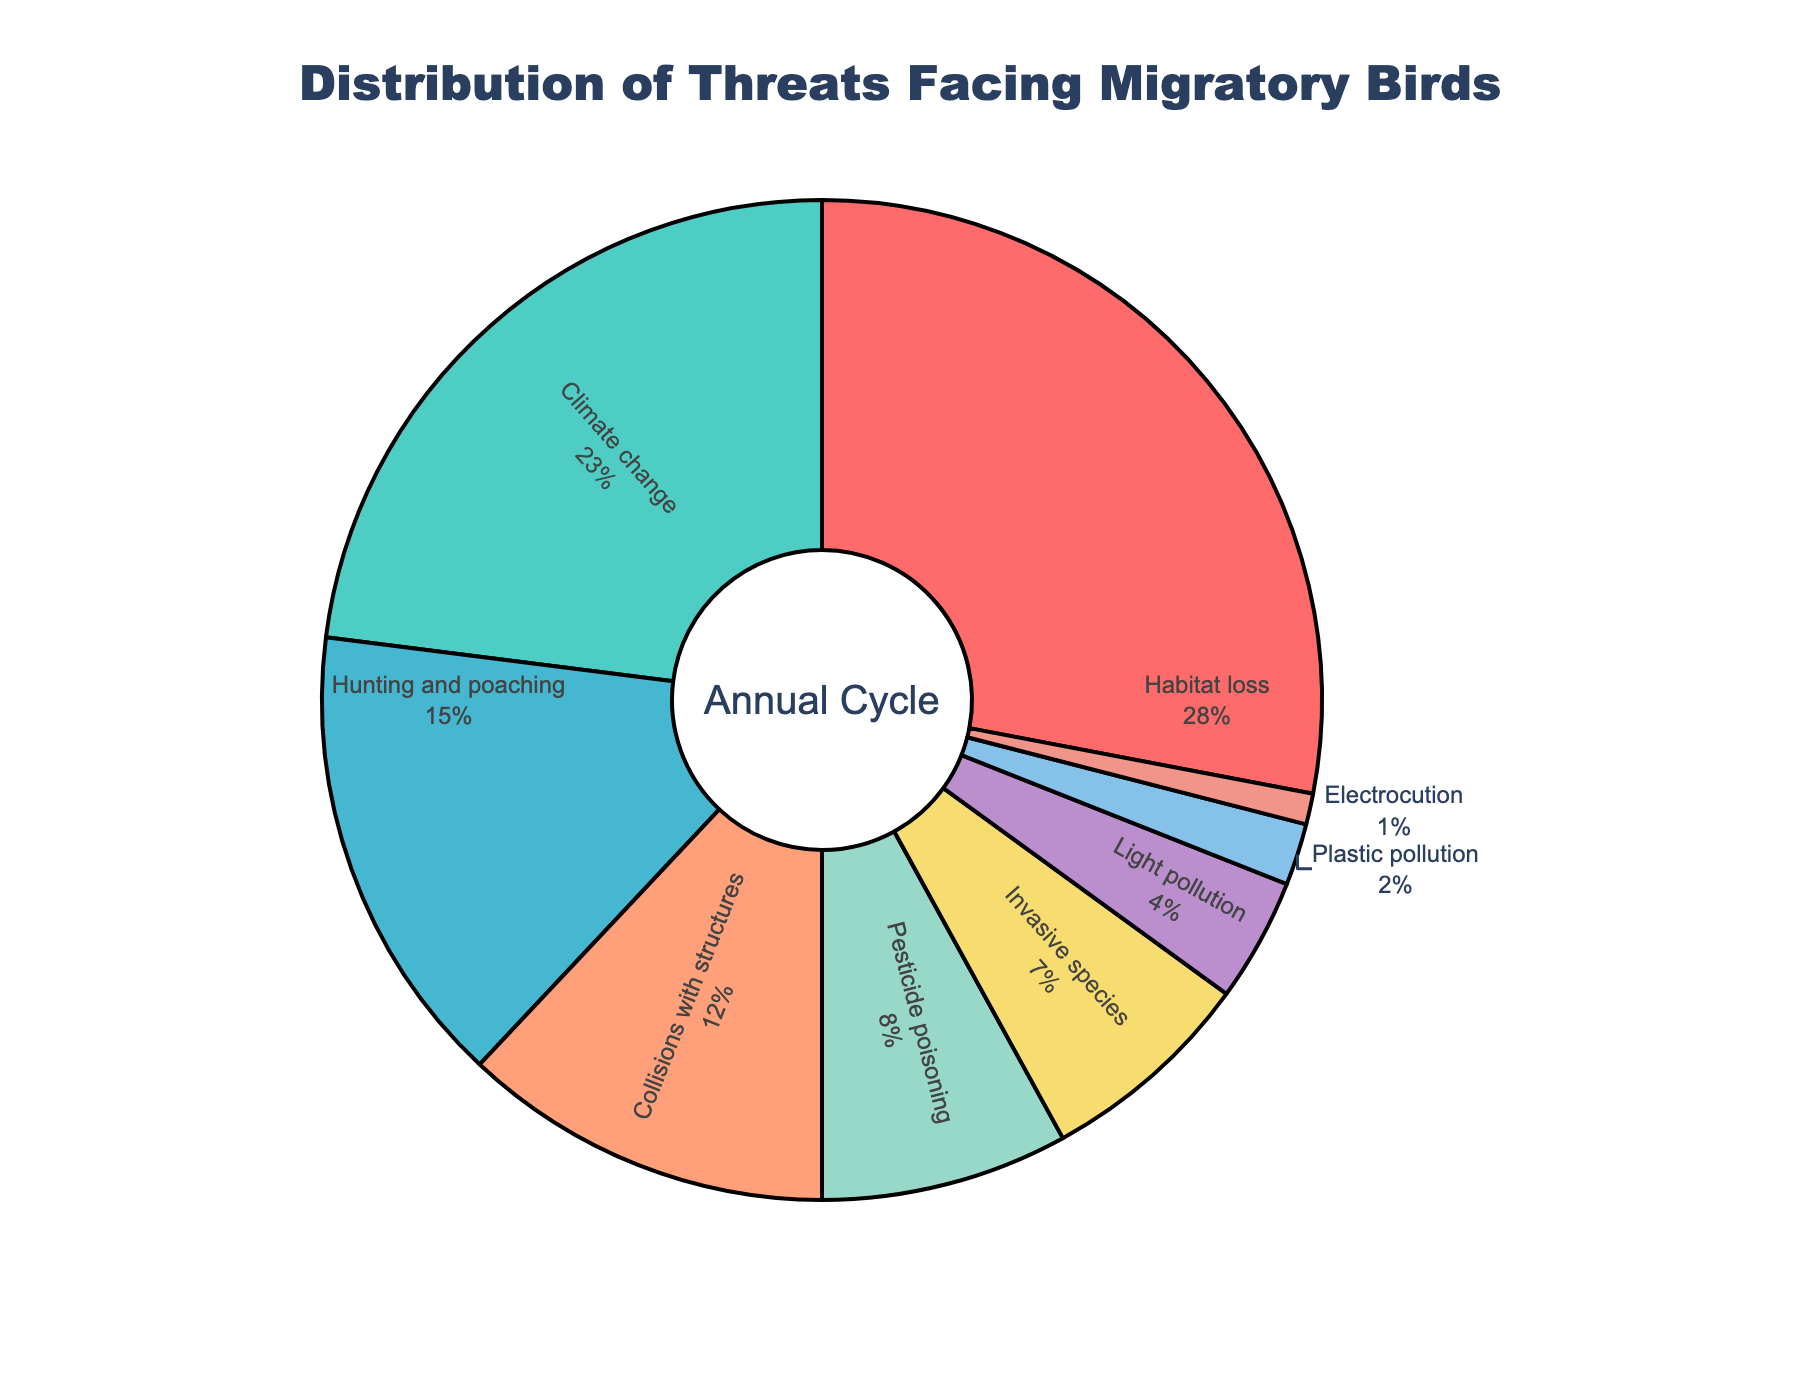What is the most significant threat facing migratory birds? According to the pie chart, the largest section represents habitat loss, which is marked with the highest percentage.
Answer: Habitat loss How much more significant is climate change compared to plastic pollution? The percentage for climate change is 23%, and for plastic pollution, it's 2%. The difference between them is 23% - 2% = 21%.
Answer: 21% Which threats together make up more than half of the total percentage? Adding the percentages of habitat loss (28%), climate change (23%), and hunting and poaching (15%) gives 28% + 23% + 15% = 66%. They collectively make up more than half.
Answer: Habitat loss, climate change, and hunting and poaching Identify the threat with the smallest representation and specify its percentage. The smallest segment in the pie chart is electrocution with a percentage of 1%.
Answer: Electrocution, 1% Between collisions with structures and light pollution, which threat has a higher representation and by how much? Collisions with structures have a percentage of 12% and light pollution 4%. Thus, 12% - 4% = 8%.
Answer: Collisions with structures, by 8% What is the combined percentage of invasive species and pesticide poisoning? The pie chart shows that invasive species are 7% and pesticide poisoning is 8%. Adding these gives 7% + 8% = 15%.
Answer: 15% Which threats are represented with less than 5% each? Light pollution, plastic pollution, and electrocution have percentages of 4%, 2%, and 1%, respectively.
Answer: Light pollution, plastic pollution, and electrocution How does the representation of hunting and poaching compare to that of pesticide poisoning? Hunting and poaching make up 15%, whereas pesticide poisoning accounts for 8%. Therefore, hunting and poaching are more significant by 15% - 8% = 7%.
Answer: Hunting and poaching, by 7% What is the total percentage represented by all threats related to pollution (light pollution and plastic pollution)? Light pollution accounts for 4% and plastic pollution for 2%. Their combined percentage is 4% + 2% = 6%.
Answer: 6% 